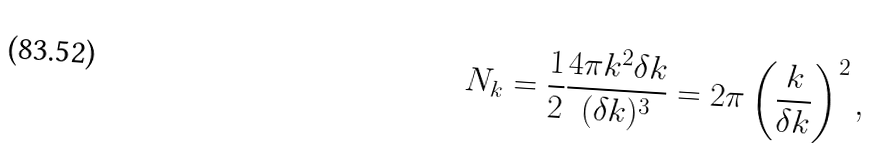Convert formula to latex. <formula><loc_0><loc_0><loc_500><loc_500>N _ { k } = \frac { 1 } { 2 } \frac { 4 \pi k ^ { 2 } \delta k } { ( \delta k ) ^ { 3 } } = 2 \pi \left ( \frac { k } { \delta k } \right ) ^ { 2 } ,</formula> 